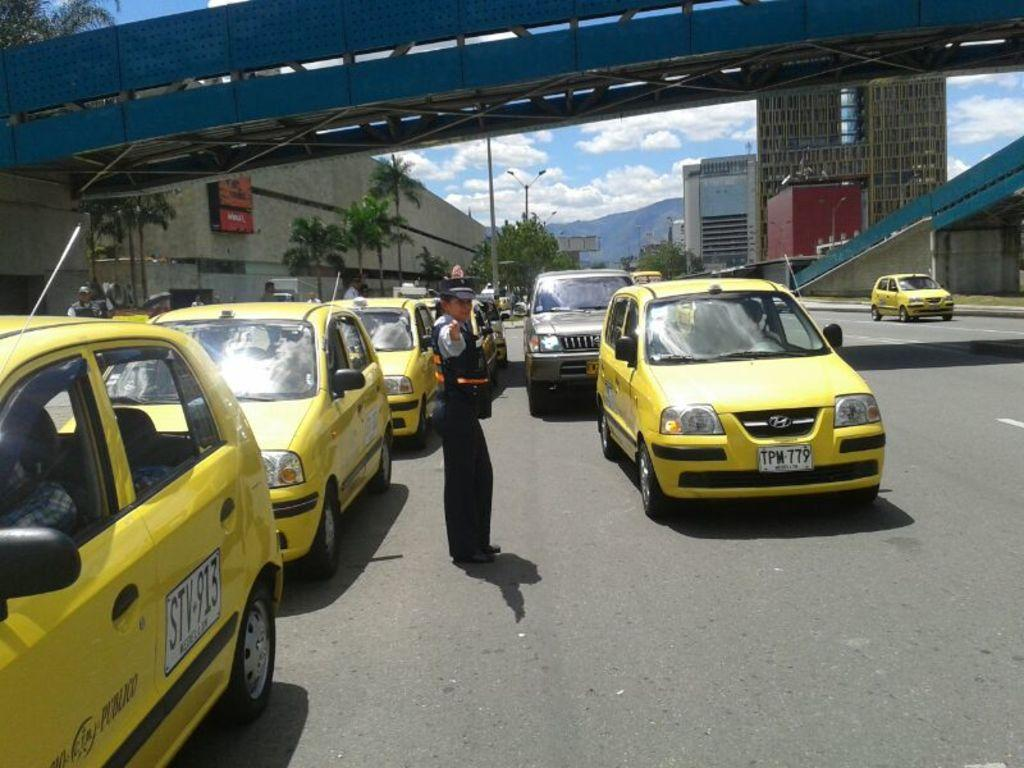Provide a one-sentence caption for the provided image. A cop directing traffic near a cab with an STV sticker on the side door. 